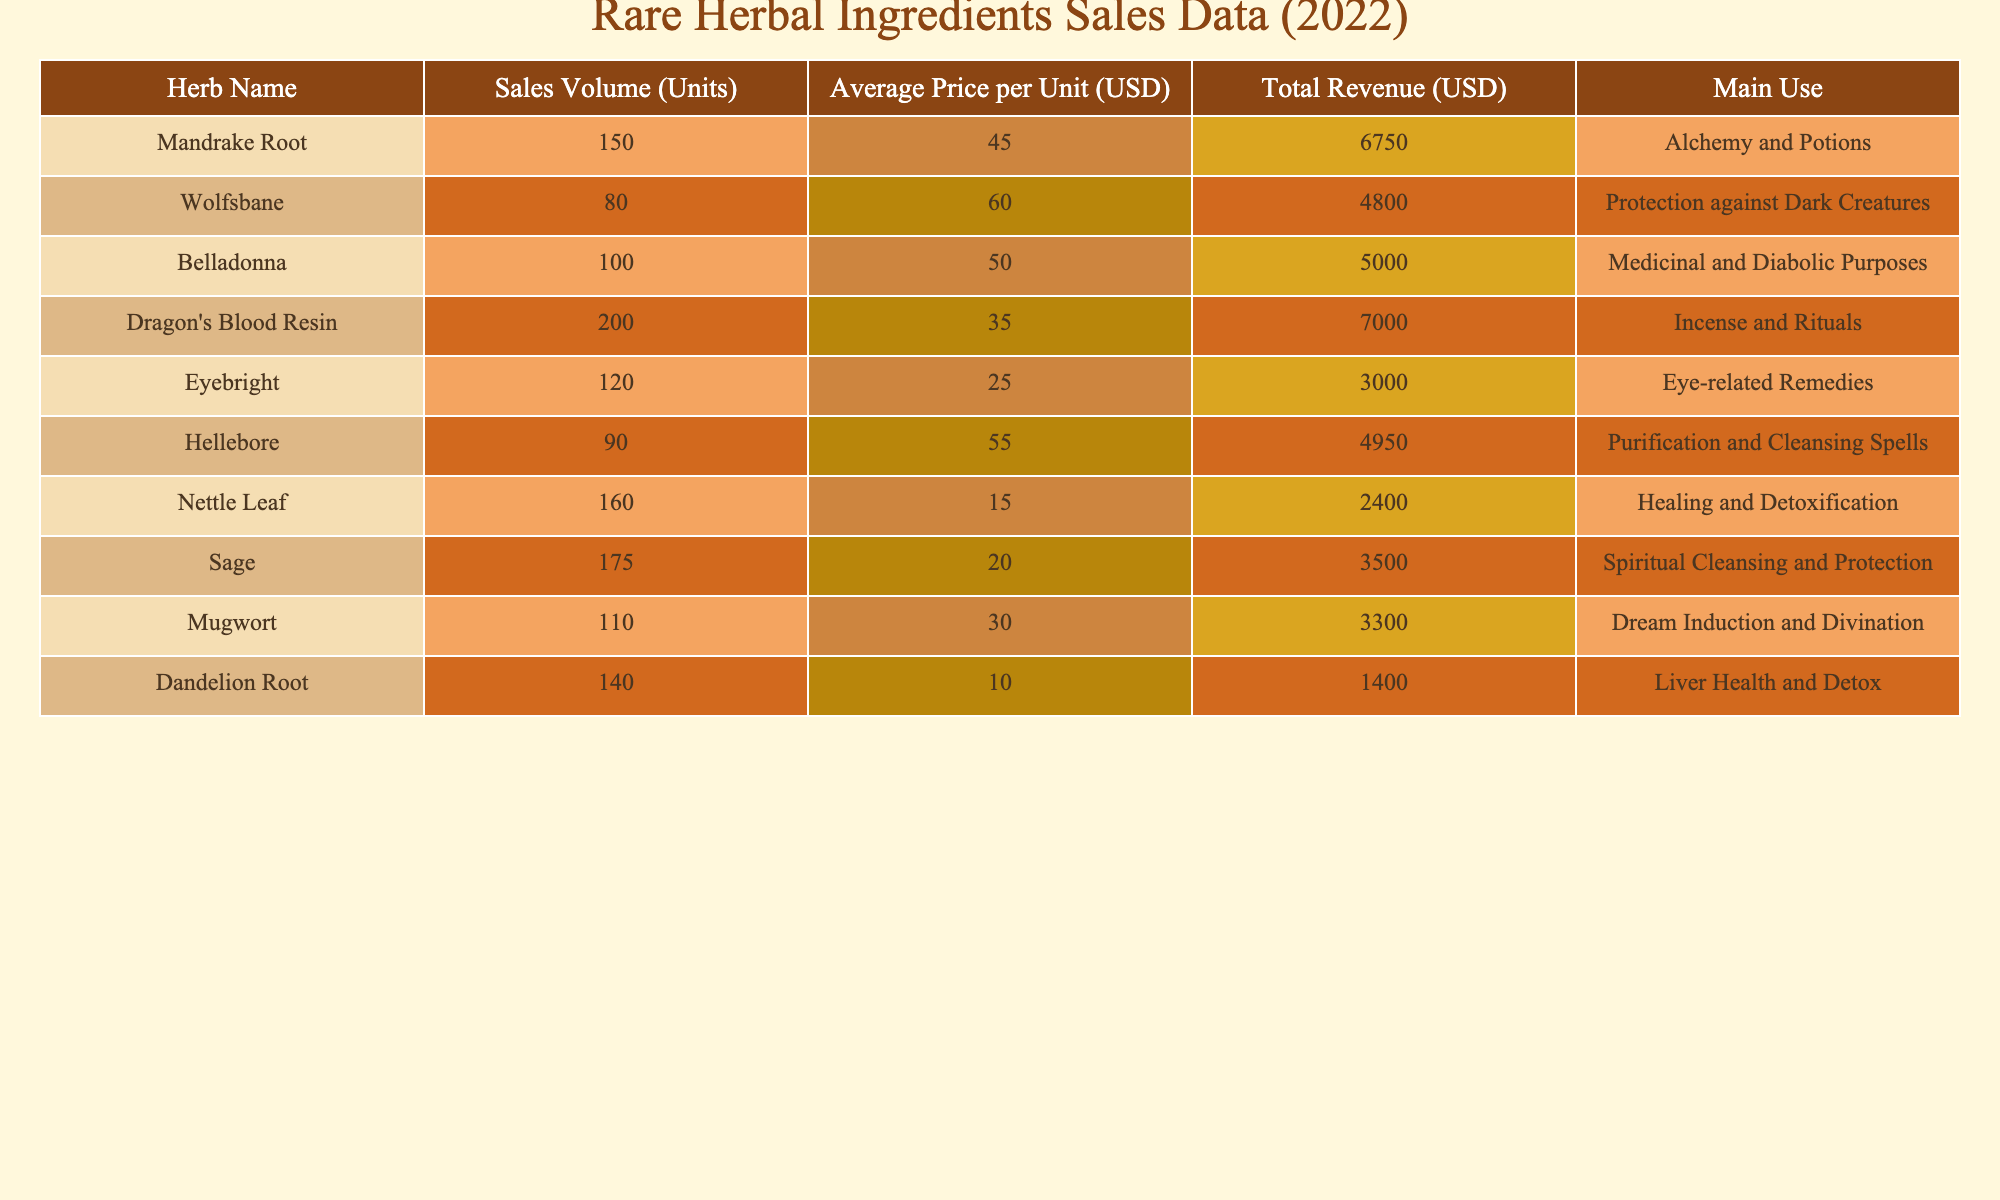What is the total revenue generated by Mandrake Root? The table shows that for Mandrake Root, the Total Revenue (USD) is listed as 6750. Therefore, the total revenue generated by Mandrake Root is directly taken from this value.
Answer: 6750 Which herb had the highest sales volume? By examining the Sales Volume (Units) column, I find that Dragon's Blood Resin has the highest value at 200 units. Therefore, Dragon's Blood Resin had the highest sales volume among the listed herbs.
Answer: Dragon's Blood Resin What is the average price per unit of Hellebore? The table lists the Average Price per Unit (USD) for Hellebore as 55.00. This exact figure is taken directly from the table, making the answer straightforward.
Answer: 55.00 What is the total revenue generated from selling Nettle Leaf and Dandelion Root combined? First, I find the Total Revenue for Nettle Leaf, which is 2400, and for Dandelion Root, it is 1400. Then, I add them together: 2400 + 1400 = 3800. Thus, the total revenue from both herbs combined is calculated.
Answer: 3800 Is the average price per unit of Eyebright higher than that of Sage? The Average Price per Unit for Eyebright is 25.00, while for Sage it is 20.00. Since 25.00 is greater than 20.00, the statement is true, confirming that Eyebright has a higher average price per unit compared to Sage.
Answer: Yes What is the total revenue for all herbs listed? To find the total revenue across all herbs, I sum the Total Revenue amounts: 6750 + 4800 + 5000 + 7000 + 3000 + 4950 + 2400 + 3500 + 3300 + 1400. This equals 37,100 after performing the addition. Therefore, the total revenue for all herbs is derived from this calculation.
Answer: 37100 Which herb has the lowest average price per unit? The Average Price per Unit for each herb is checked, and Nettle Leaf at 15.00 is found to have the lowest price. Thus, Nettle Leaf is confirmed as the herb with the lowest average price per unit.
Answer: Nettle Leaf How many units of Wolfsbane were sold? The Sales Volume (Units) for Wolfsbane listed in the table is 80. This number is taken directly from the Sales Volume column as part of the specifics on Wolfsbane.
Answer: 80 Which herbs have medicinal uses? Looking at the Main Use column, both Belladonna and Nettle Leaf are noted as having medicinal purposes. Therefore, summarizing this requires simply identifying the specific herbs with related mentions under their uses.
Answer: Belladonna, Nettle Leaf 